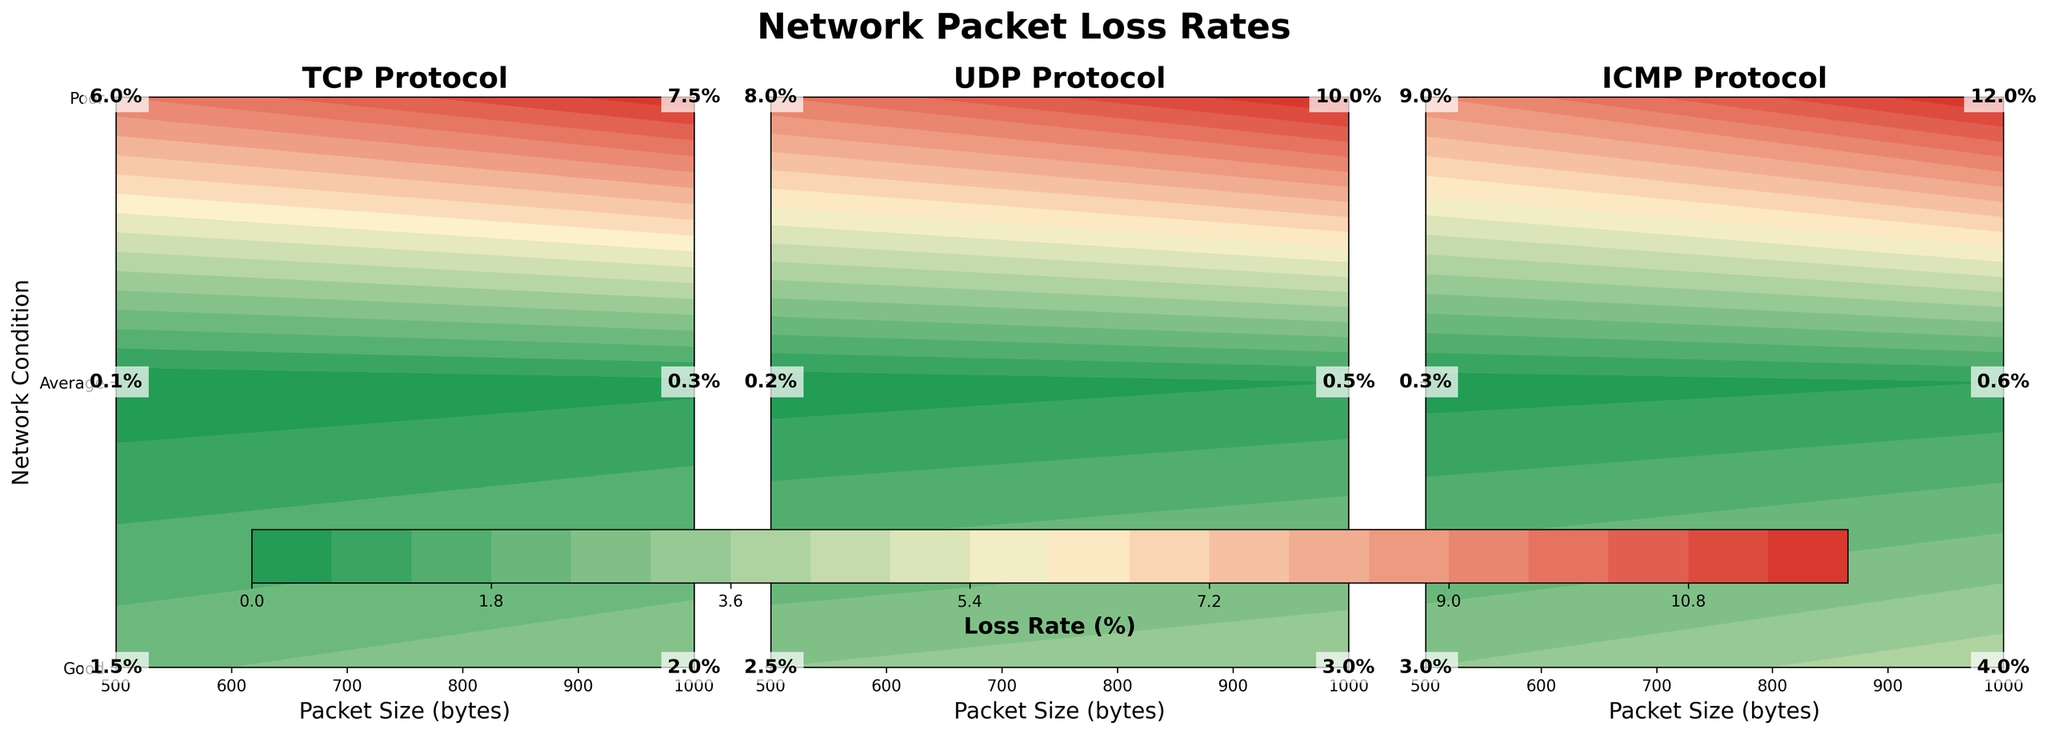What's the title of the figure? The title of the figure is located at the top and it summarizes the overall content. It reads 'Network Packet Loss Rates'.
Answer: Network Packet Loss Rates Which protocol shows the highest loss rate for a 1000 byte packet under poor network conditions? Locate the area corresponding to the 1000 byte packet and poor network conditions for each protocol, and compare the values. ICMP has the highest packet loss rate of 12.0%.
Answer: ICMP What is the loss rate for UDP with a 500 byte packet under average network conditions? Find the section for UDP protocol, then look at the intersection of 500 byte packet size and average network condition. The value is 2.5%.
Answer: 2.5% Compare the loss rates between TCP and UDP for a 500 byte packet under good network conditions. Which is higher? Check the loss rates in the 'Good' row for a 500 byte packet size for TCP (0.1%) and UDP (0.2%). UDP has a higher loss rate.
Answer: UDP On average, which protocol performs better for a 1000 byte packet under average network conditions? Average the loss rates under 'Average' for the protocols with 1000 byte packets. TCP (2.0%), UDP (3.0%), ICMP (4.0%). TCP has the lowest average loss rate.
Answer: TCP How many distinct network conditions are used in the figure? Look at the y-axis labels across the different subplots. The distinct network conditions are Good, Average, and Poor, totaling three distinct conditions.
Answer: 3 What's the difference in loss rate between the best and worst network conditions for TCP with a 500 byte packet size? For TCP with a 500 byte packet, the loss rate under Good is 0.1% and Poor is 6.0%. The difference: 6.0% - 0.1% = 5.9%.
Answer: 5.9% Which protocol exhibits the largest increase in loss rate between good and poor network conditions for 1000 byte packets? Calculate the increase from 'Good' to 'Poor' for each protocol for a 1000 byte packet. TCP: 7.2% (7.5% - 0.3%), UDP: 9.5% (10.0% - 0.5%), ICMP: 11.4% (12.0% - 0.6%). ICMP has the largest increase.
Answer: ICMP Describe the color gradient used in the contour plot. The color gradient transitions from green to yellow to red, indicating increasing packet loss rates from low to high.
Answer: Green to Yellow to Red 